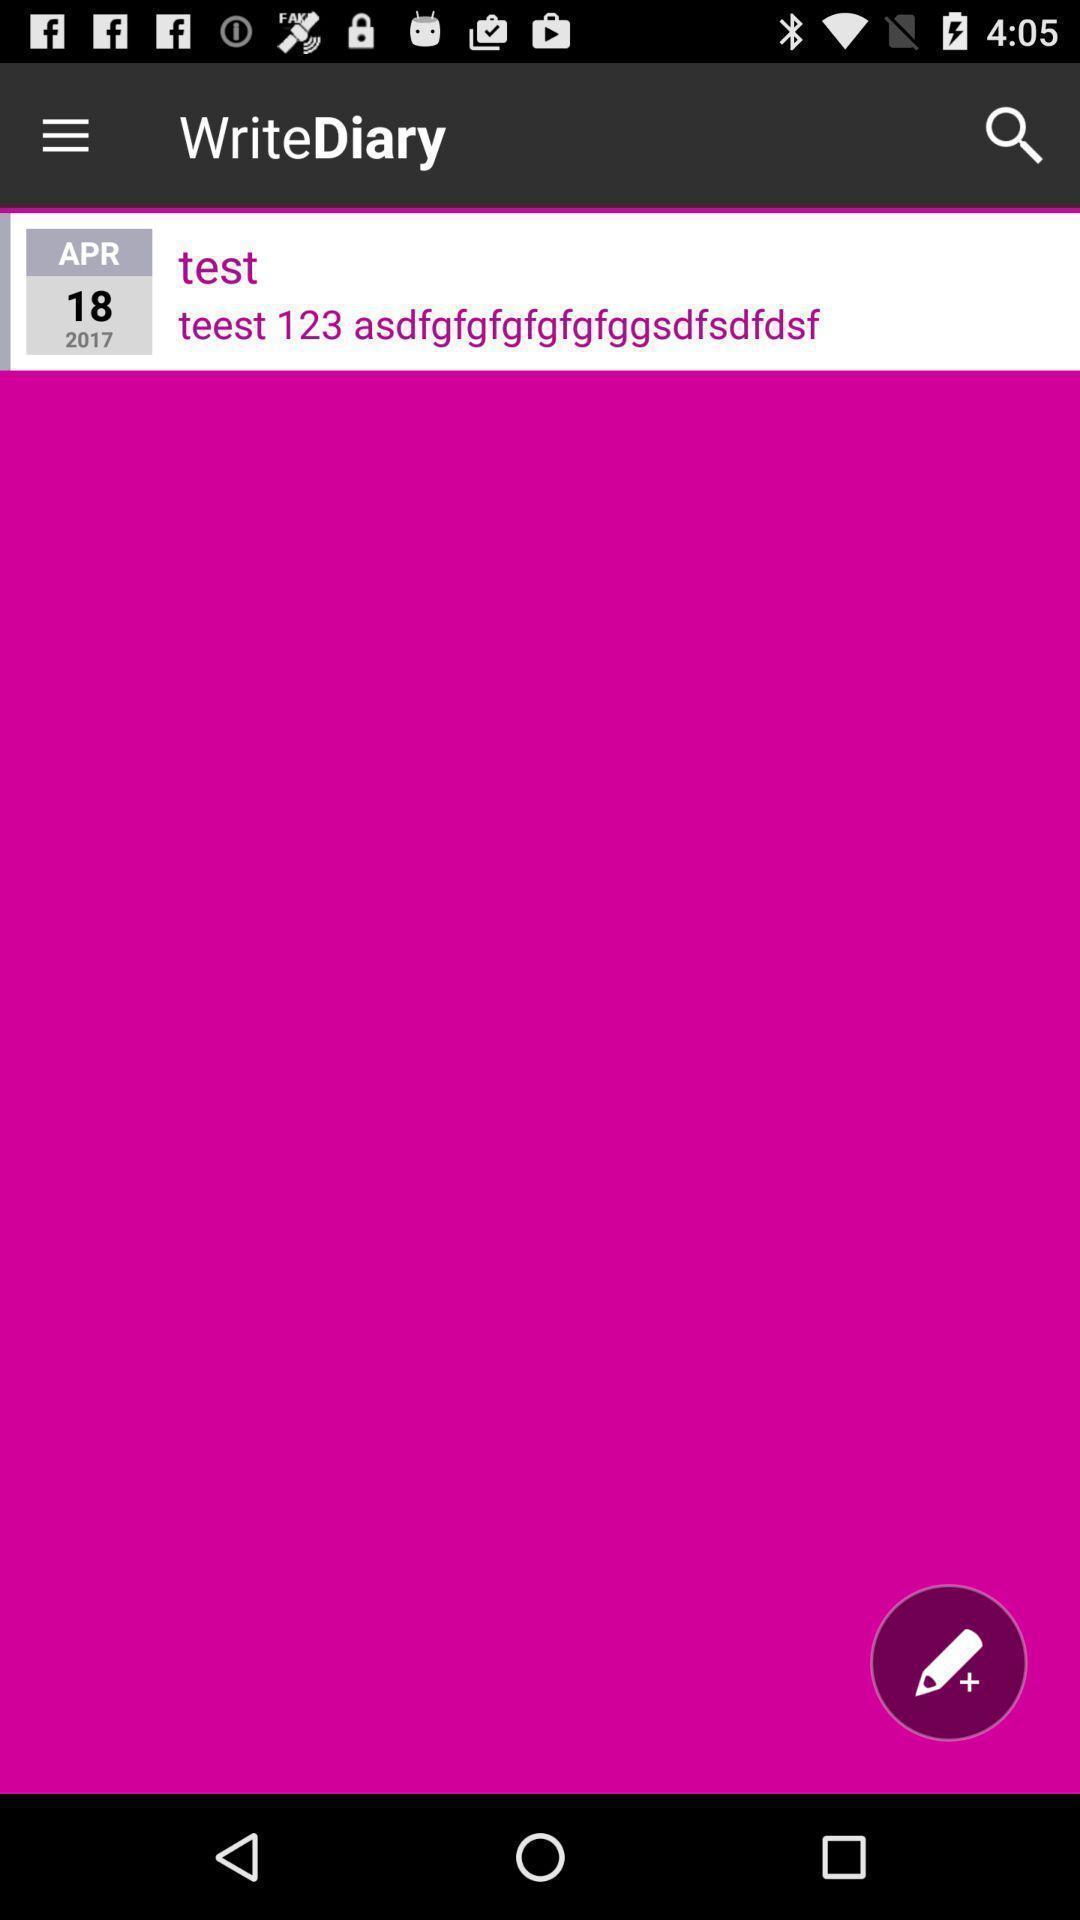Describe the content in this image. Page displaying with saved text in diary application. 